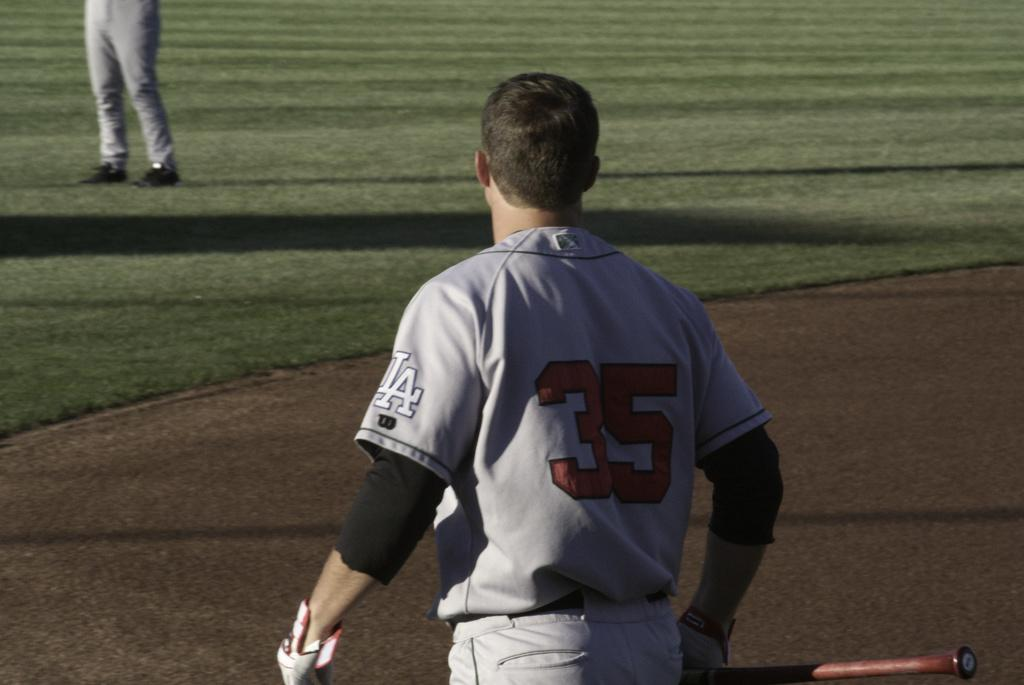<image>
Create a compact narrative representing the image presented. A baseball player is holding a red bat and wearing a grey jersey that says LA 35. 